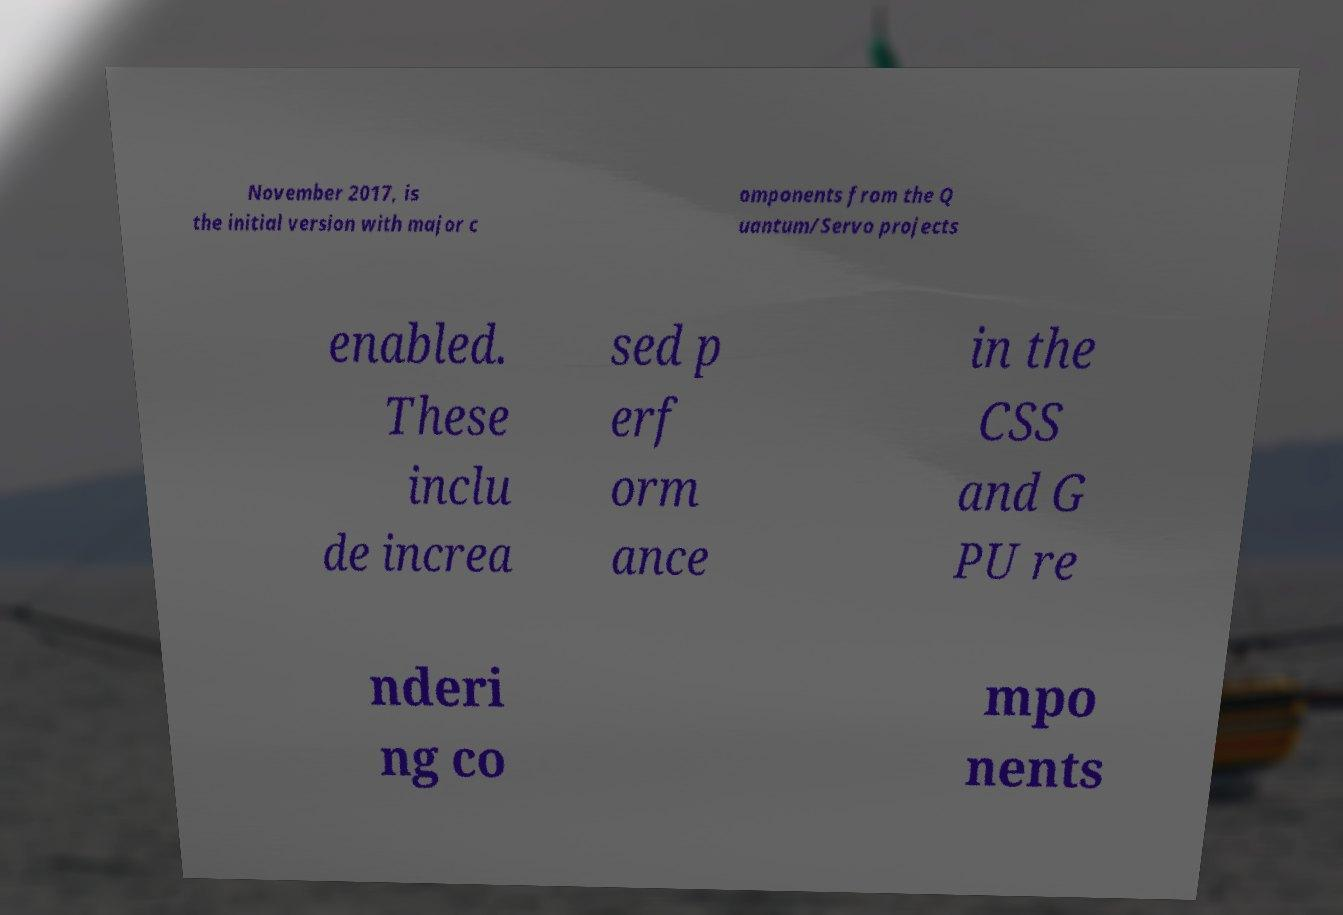Please identify and transcribe the text found in this image. November 2017, is the initial version with major c omponents from the Q uantum/Servo projects enabled. These inclu de increa sed p erf orm ance in the CSS and G PU re nderi ng co mpo nents 